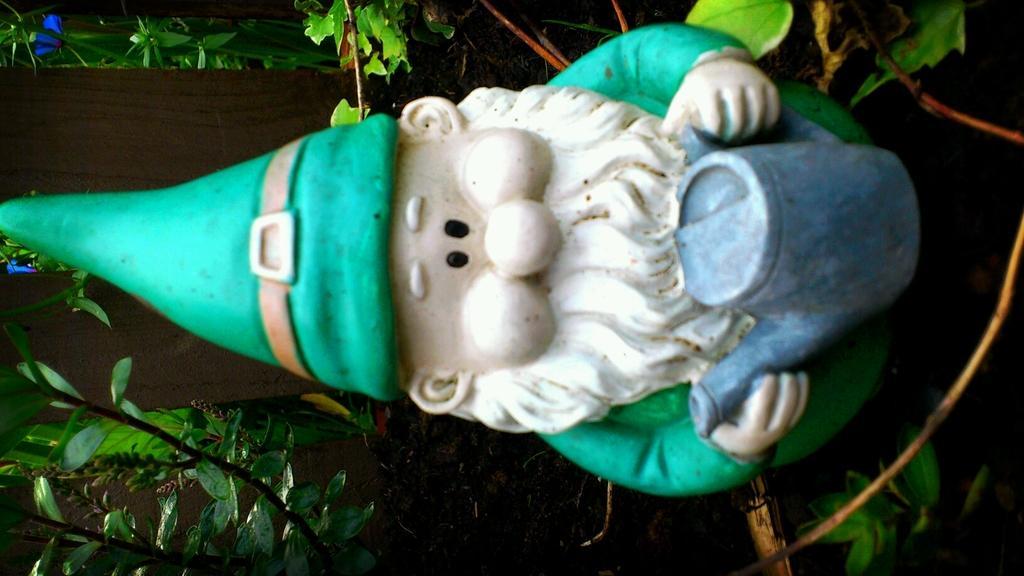Can you describe this image briefly? It is a tilted image, there is a small sculpture and around that there are many plants. 